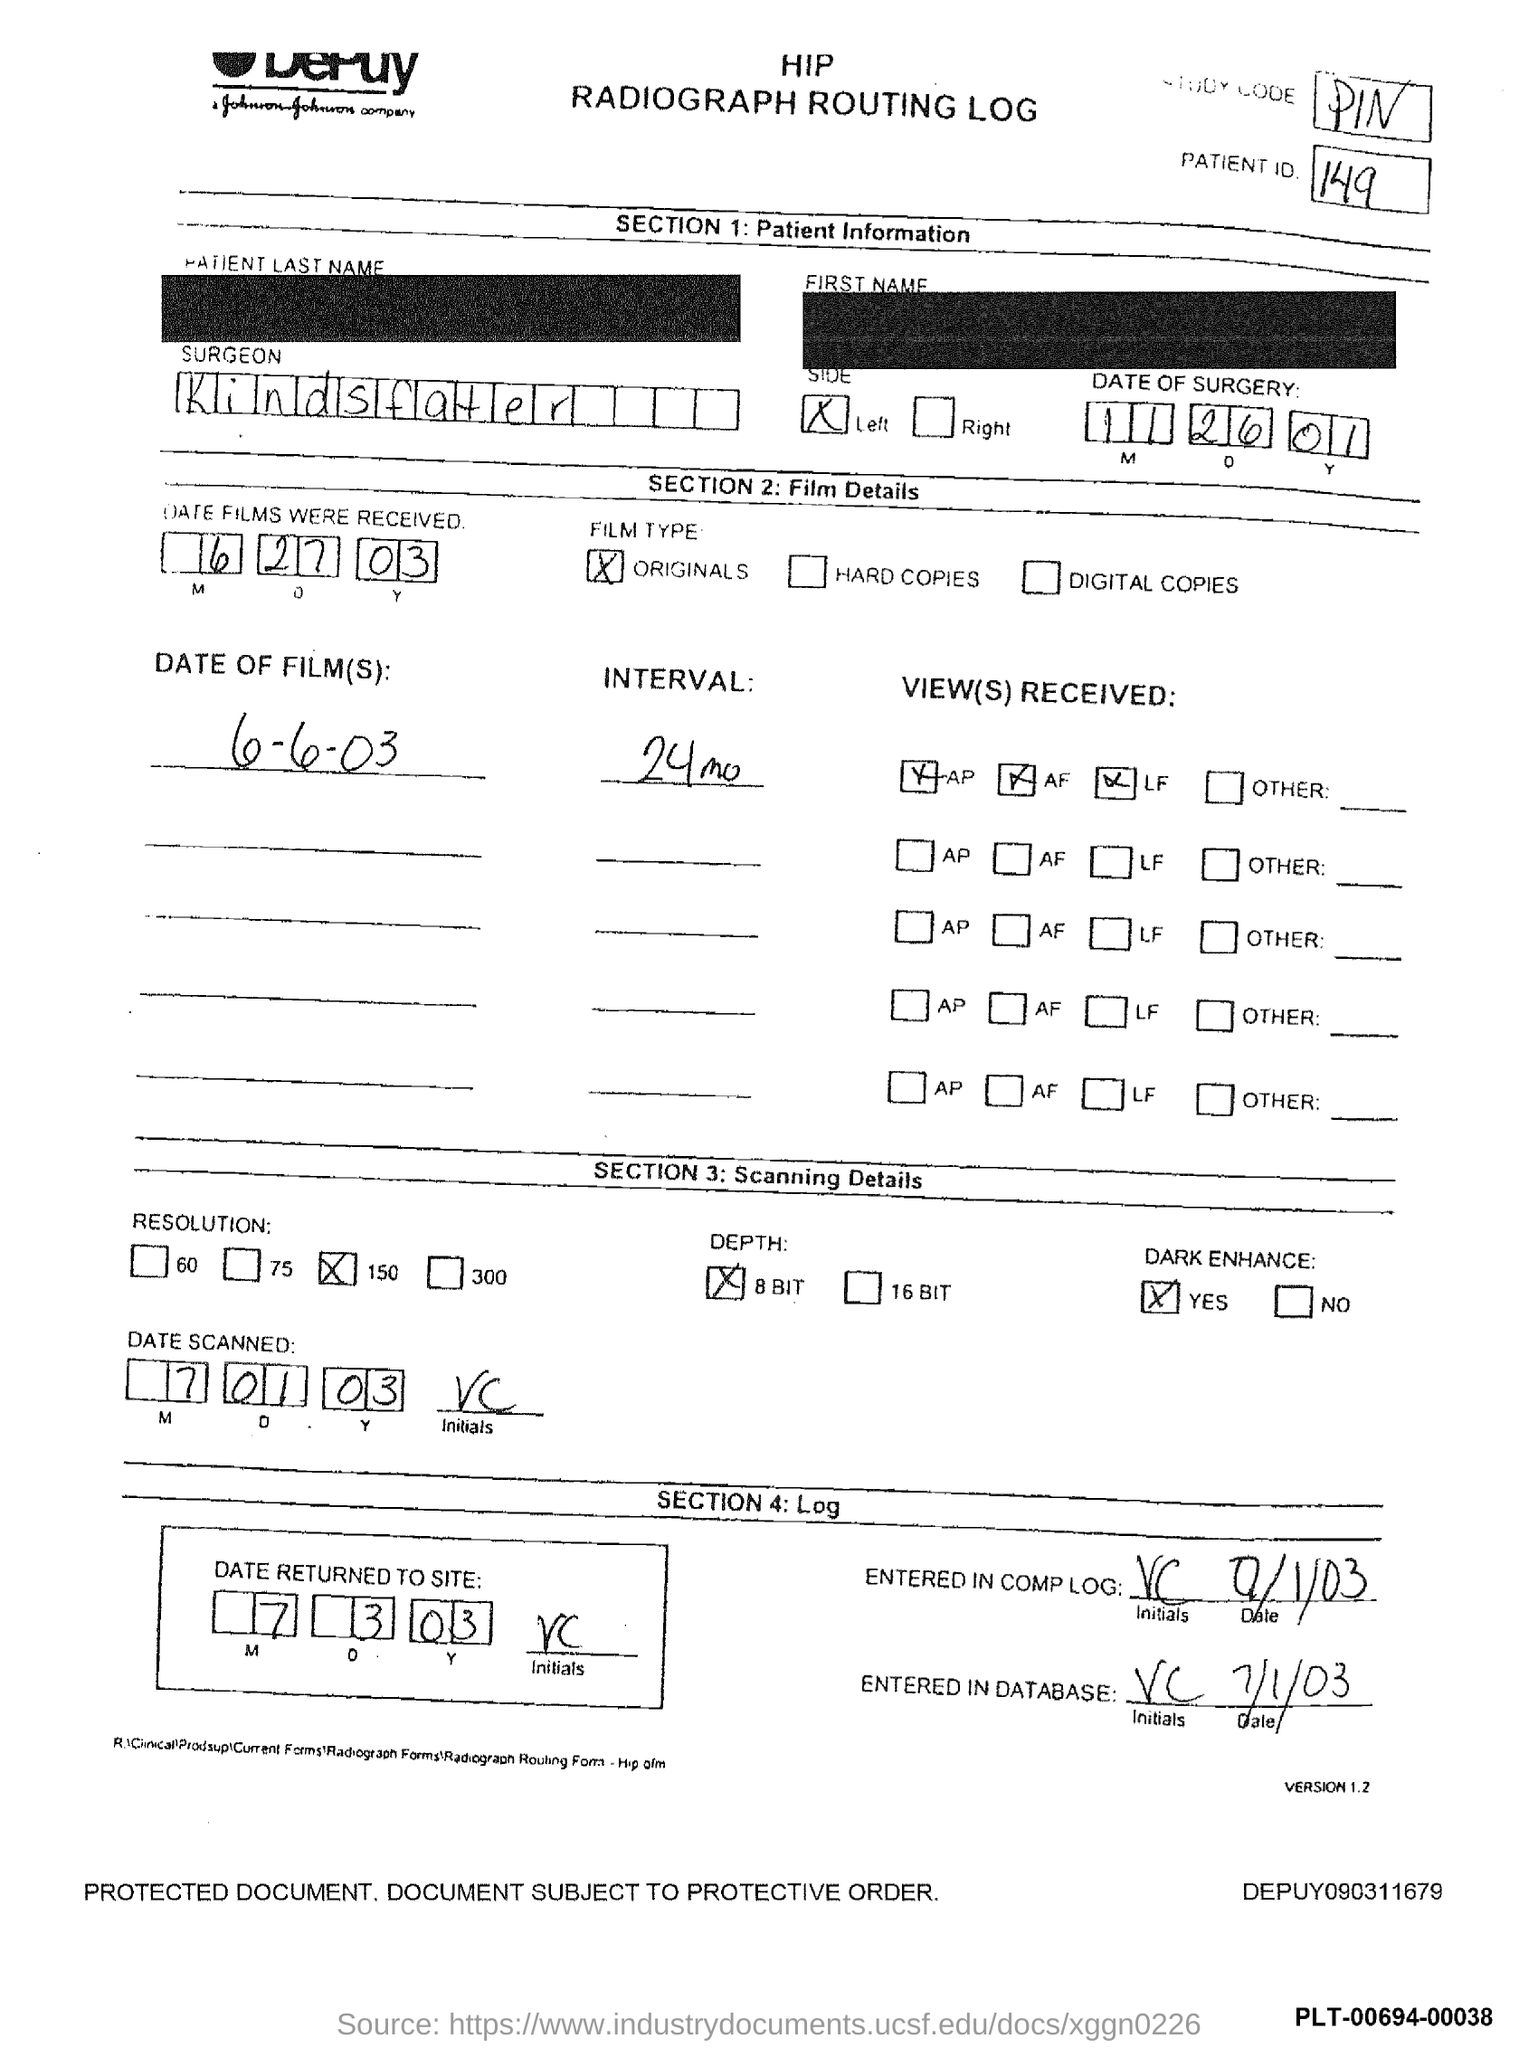Identify some key points in this picture. The surgeon's name is Kindsfater. The patient ID is 149. 